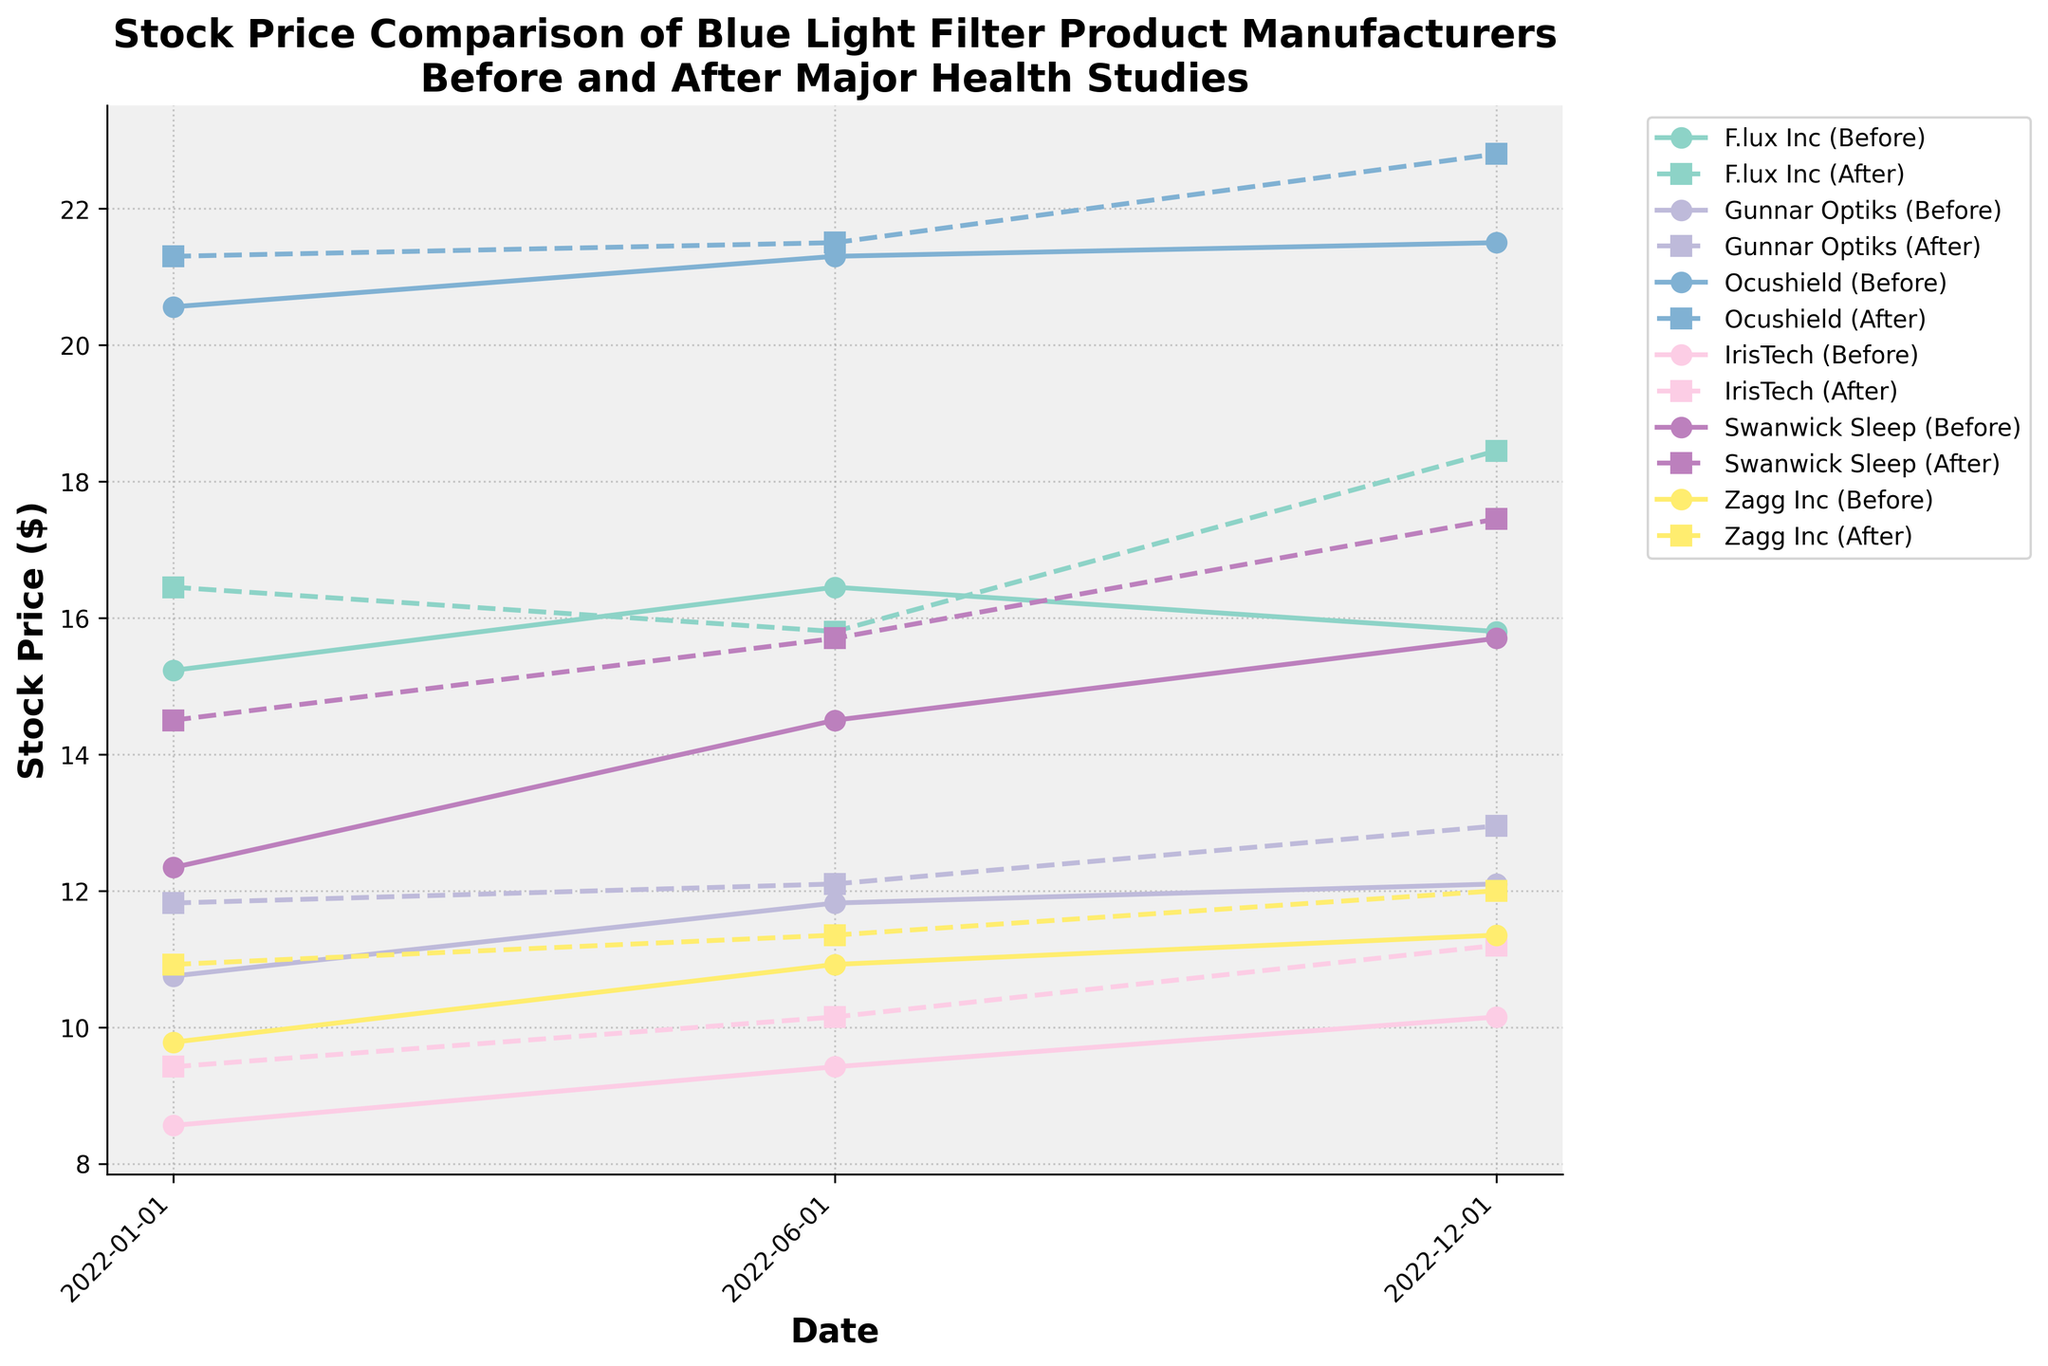What is the title of the figure? The title is displayed at the top of the figure and reads: 'Stock Price Comparison of Blue Light Filter Product Manufacturers Before and After Major Health Studies.'
Answer: Stock Price Comparison of Blue Light Filter Product Manufacturers Before and After Major Health Studies Which company had the highest stock price after the study in December 2022? Based on the data visualized in December 2022, Ocushield has the highest stock price after the study, as indicated by the plotted points for that month.
Answer: Ocushield How did Swanwick Sleep's stock price change from January 2022 to December 2022 after the studies? To find this, we need to look at Swanwick Sleep's stock prices after the studies for both January 2022 and December 2022. In January 2022, the after-study stock price was $14.50. By December 2022, it was $17.45. Subtract $14.50 from $17.45 to find the change.
Answer: $2.95 increase Did F.lux Inc's stock price increase or decrease from June 2022 to December 2022 after the studies? For F.lux Inc., first look at the after-study stock prices for June 2022 and December 2022. In June 2022, it was $15.80, and in December 2022, it was $18.45. The stock price increased ($18.45 - $15.80 = $2.65).
Answer: Increased Which company showed the most consistent increase in stock prices after the studies throughout the year 2022? To determine the most consistent increase, examine the after-study stock prices for each company across January, June, and December 2022. Ocushield shows a steady increase from $21.30 in January to $21.50 in June and $22.80 in December.
Answer: Ocushield What significant trend can be observed for IrisTech's stock price before and after the studies in 2022? Observing the stock prices before and after for IrisTech, there is a consistent increase after each health study (from $8.56 to $9.42 in January, from $9.42 to $10.15 in June, and from $10.15 to $11.20 in December).
Answer: Consistent increase after studies By how much did Zagg Inc's stock price change from June 2022 to December 2022 before the studies? Check Zagg Inc's stock prices for June and December 2022 before the studies. In June 2022, it was $10.92, and in December 2022, it was $11.35. Calculate the change by subtracting $10.92 from $11.35.
Answer: Increase by $0.43 